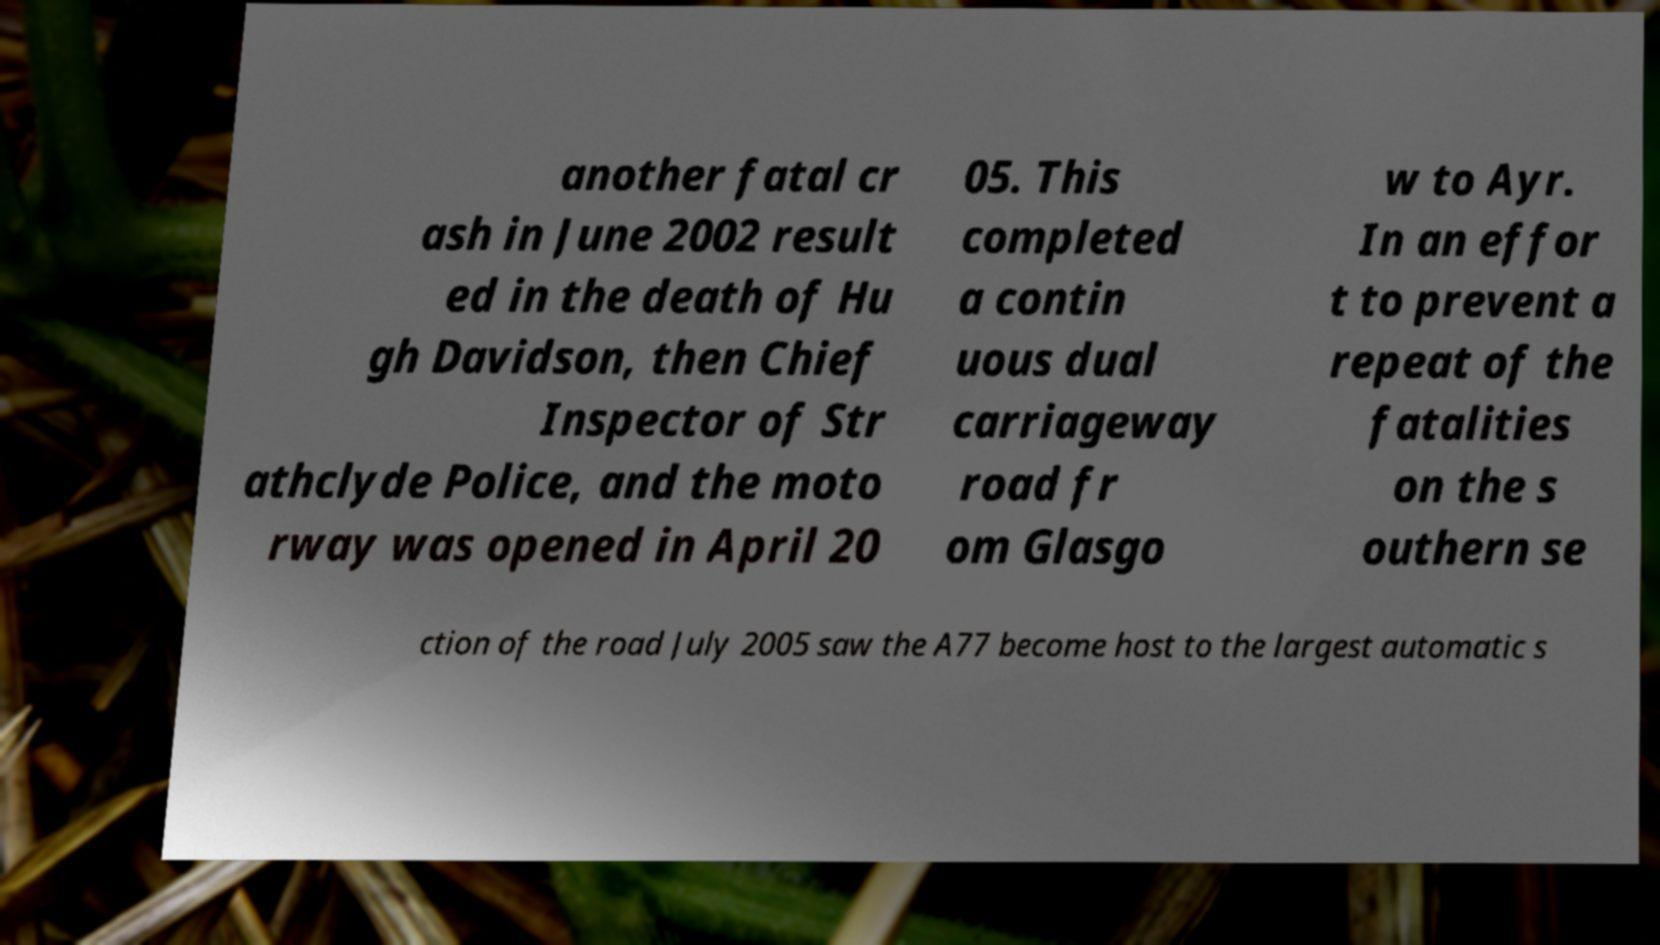I need the written content from this picture converted into text. Can you do that? another fatal cr ash in June 2002 result ed in the death of Hu gh Davidson, then Chief Inspector of Str athclyde Police, and the moto rway was opened in April 20 05. This completed a contin uous dual carriageway road fr om Glasgo w to Ayr. In an effor t to prevent a repeat of the fatalities on the s outhern se ction of the road July 2005 saw the A77 become host to the largest automatic s 